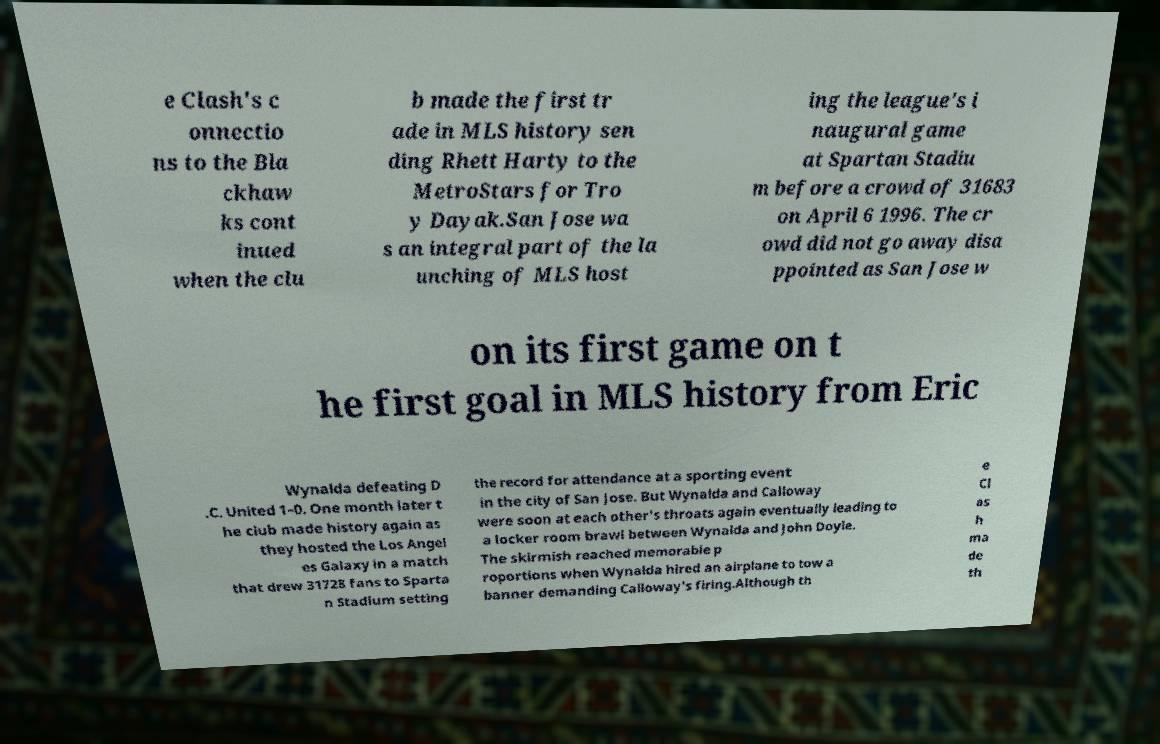Please read and relay the text visible in this image. What does it say? e Clash's c onnectio ns to the Bla ckhaw ks cont inued when the clu b made the first tr ade in MLS history sen ding Rhett Harty to the MetroStars for Tro y Dayak.San Jose wa s an integral part of the la unching of MLS host ing the league's i naugural game at Spartan Stadiu m before a crowd of 31683 on April 6 1996. The cr owd did not go away disa ppointed as San Jose w on its first game on t he first goal in MLS history from Eric Wynalda defeating D .C. United 1–0. One month later t he club made history again as they hosted the Los Angel es Galaxy in a match that drew 31728 fans to Sparta n Stadium setting the record for attendance at a sporting event in the city of San Jose. But Wynalda and Calloway were soon at each other's throats again eventually leading to a locker room brawl between Wynalda and John Doyle. The skirmish reached memorable p roportions when Wynalda hired an airplane to tow a banner demanding Calloway's firing.Although th e Cl as h ma de th 